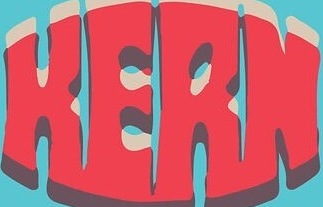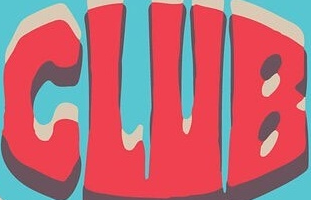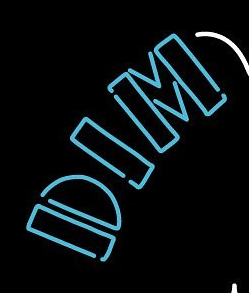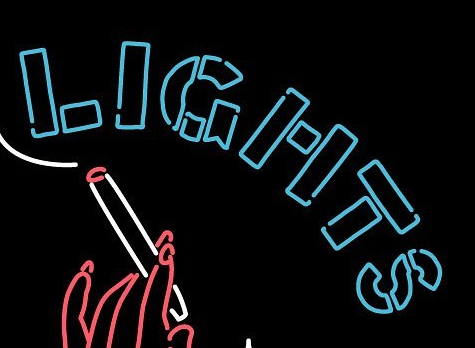Transcribe the words shown in these images in order, separated by a semicolon. HERN; CLUB; DIM; LIGHTS 